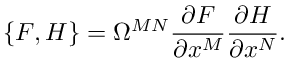<formula> <loc_0><loc_0><loc_500><loc_500>\{ F , H \} = \Omega ^ { M N } \frac { \partial F } { \partial x ^ { M } } \frac { \partial H } { \partial x ^ { N } } .</formula> 